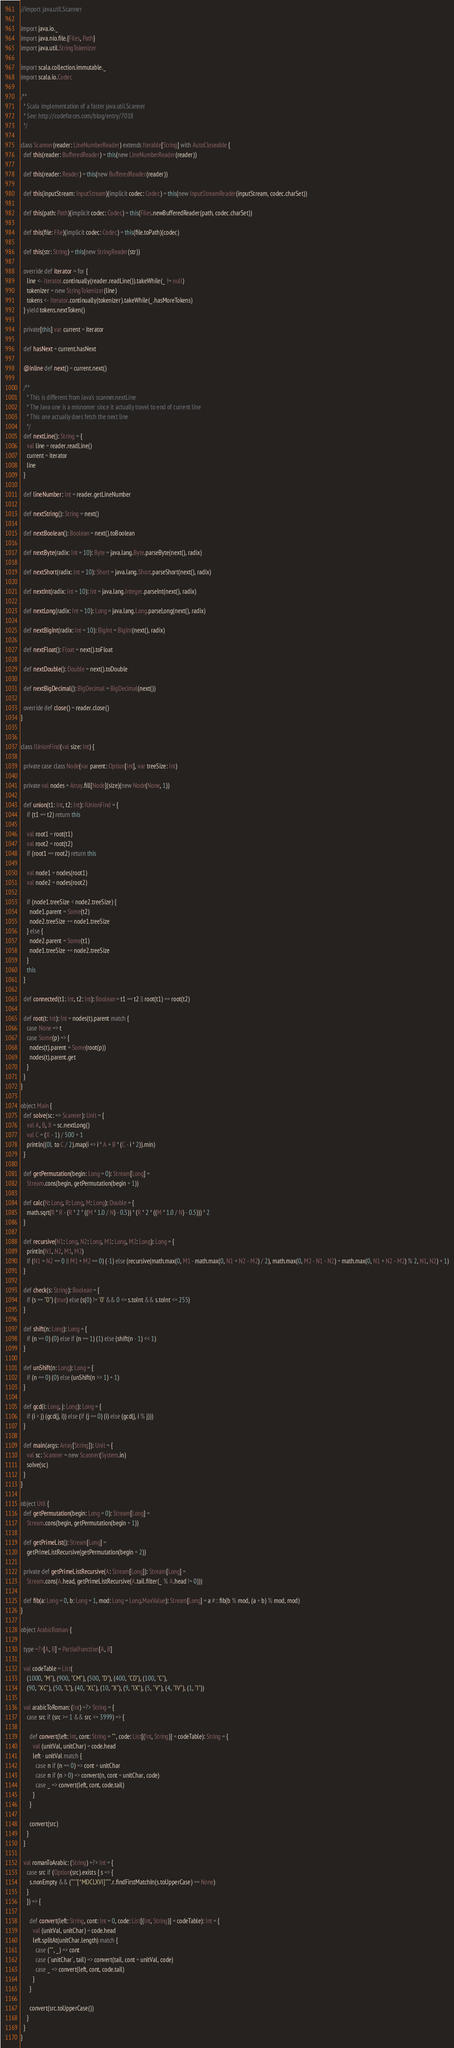<code> <loc_0><loc_0><loc_500><loc_500><_Scala_>//import java.util.Scanner

import java.io._
import java.nio.file.{Files, Path}
import java.util.StringTokenizer

import scala.collection.immutable._
import scala.io.Codec

/**
  * Scala implementation of a faster java.util.Scanner
  * See: http://codeforces.com/blog/entry/7018
  */

class Scanner(reader: LineNumberReader) extends Iterable[String] with AutoCloseable {
  def this(reader: BufferedReader) = this(new LineNumberReader(reader))

  def this(reader: Reader) = this(new BufferedReader(reader))

  def this(inputStream: InputStream)(implicit codec: Codec) = this(new InputStreamReader(inputStream, codec.charSet))

  def this(path: Path)(implicit codec: Codec) = this(Files.newBufferedReader(path, codec.charSet))

  def this(file: File)(implicit codec: Codec) = this(file.toPath)(codec)

  def this(str: String) = this(new StringReader(str))

  override def iterator = for {
    line <- Iterator.continually(reader.readLine()).takeWhile(_ != null)
    tokenizer = new StringTokenizer(line)
    tokens <- Iterator.continually(tokenizer).takeWhile(_.hasMoreTokens)
  } yield tokens.nextToken()

  private[this] var current = iterator

  def hasNext = current.hasNext

  @inline def next() = current.next()

  /**
    * This is different from Java's scanner.nextLine
    * The Java one is a misnomer since it actually travel to end of current line
    * This one actually does fetch the next line
    */
  def nextLine(): String = {
    val line = reader.readLine()
    current = iterator
    line
  }

  def lineNumber: Int = reader.getLineNumber

  def nextString(): String = next()

  def nextBoolean(): Boolean = next().toBoolean

  def nextByte(radix: Int = 10): Byte = java.lang.Byte.parseByte(next(), radix)

  def nextShort(radix: Int = 10): Short = java.lang.Short.parseShort(next(), radix)

  def nextInt(radix: Int = 10): Int = java.lang.Integer.parseInt(next(), radix)

  def nextLong(radix: Int = 10): Long = java.lang.Long.parseLong(next(), radix)

  def nextBigInt(radix: Int = 10): BigInt = BigInt(next(), radix)

  def nextFloat(): Float = next().toFloat

  def nextDouble(): Double = next().toDouble

  def nextBigDecimal(): BigDecimal = BigDecimal(next())

  override def close() = reader.close()
}


class IUnionFind(val size: Int) {

  private case class Node(var parent: Option[Int], var treeSize: Int)

  private val nodes = Array.fill[Node](size)(new Node(None, 1))

  def union(t1: Int, t2: Int): IUnionFind = {
    if (t1 == t2) return this

    val root1 = root(t1)
    val root2 = root(t2)
    if (root1 == root2) return this

    val node1 = nodes(root1)
    val node2 = nodes(root2)

    if (node1.treeSize < node2.treeSize) {
      node1.parent = Some(t2)
      node2.treeSize += node1.treeSize
    } else {
      node2.parent = Some(t1)
      node1.treeSize += node2.treeSize
    }
    this
  }

  def connected(t1: Int, t2: Int): Boolean = t1 == t2 || root(t1) == root(t2)

  def root(t: Int): Int = nodes(t).parent match {
    case None => t
    case Some(p) => {
      nodes(t).parent = Some(root(p))
      nodes(t).parent.get
    }
  }
}

object Main {
  def solve(sc: => Scanner): Unit = {
    val A, B, X = sc.nextLong()
    val C = (X - 1) / 500 + 1
    println((0L to C / 2).map(i => i * A + B * (C - i * 2)).min)
  }

  def getPermutation(begin: Long = 0): Stream[Long] =
    Stream.cons(begin, getPermutation(begin + 1))

  def calc(N: Long, R: Long, M: Long): Double = {
    math.sqrt(R * R - (R * 2 * ((M * 1.0 / N) - 0.5)) * (R * 2 * ((M * 1.0 / N) - 0.5))) * 2
  }

  def recursive(N1: Long, N2: Long, M1: Long, M2: Long): Long = {
    println(N1, N2, M1, M2)
    if (N1 + N2 == 0 || M1 + M2 == 0) (-1) else (recursive(math.max(0, M1 - math.max(0, N1 + N2 - M2) / 2), math.max(0, M2 - N1 - N2) + math.max(0, N1 + N2 - M2) % 2, N1, N2) + 1)
  }

  def check(s: String): Boolean = {
    if (s == "0") (true) else (s(0) != '0' && 0 <= s.toInt && s.toInt <= 255)
  }

  def shift(n: Long): Long = {
    if (n == 0) (0) else if (n == 1) (1) else (shift(n - 1) << 1)
  }

  def unShift(n: Long): Long = {
    if (n == 0) (0) else (unShift(n >> 1) + 1)
  }

  def gcd(i: Long, j: Long): Long = {
    if (i < j) (gcd(j, i)) else (if (j == 0) (i) else (gcd(j, i % j)))
  }

  def main(args: Array[String]): Unit = {
    val sc: Scanner = new Scanner(System.in)
    solve(sc)
  }
}

object Util {
  def getPermutation(begin: Long = 0): Stream[Long] =
    Stream.cons(begin, getPermutation(begin + 1))

  def getPrimeList(): Stream[Long] =
    getPrimeListRecursive(getPermutation(begin = 2))

  private def getPrimeListRecursive(A: Stream[Long]): Stream[Long] =
    Stream.cons(A.head, getPrimeListRecursive(A.tail.filter(_ % A.head != 0)))

  def fib(a: Long = 0, b: Long = 1, mod: Long = Long.MaxValue): Stream[Long] = a #:: fib(b % mod, (a + b) % mod, mod)
}

object ArabicRoman {

  type =?>[A, B] = PartialFunction[A, B]

  val codeTable = List(
    (1000, "M"), (900, "CM"), (500, "D"), (400, "CD"), (100, "C"),
    (90, "XC"), (50, "L"), (40, "XL"), (10, "X"), (9, "IX"), (5, "V"), (4, "IV"), (1, "I"))

  val arabicToRoman: (Int) =?> String = {
    case src if (src >= 1 && src <= 3999) => {

      def convert(left: Int, cont: String = "", code: List[(Int, String)] = codeTable): String = {
        val (unitVal, unitChar) = code.head
        left - unitVal match {
          case n if (n == 0) => cont + unitChar
          case n if (n > 0) => convert(n, cont + unitChar, code)
          case _ => convert(left, cont, code.tail)
        }
      }

      convert(src)
    }
  }

  val romanToArabic: (String) =?> Int = {
    case src if (Option(src).exists { s => {
      s.nonEmpty && ("""[^MDCLXVI]""".r.findFirstMatchIn(s.toUpperCase) == None)
    }
    }) => {

      def convert(left: String, cont: Int = 0, code: List[(Int, String)] = codeTable): Int = {
        val (unitVal, unitChar) = code.head
        left.splitAt(unitChar.length) match {
          case ("", _) => cont
          case (`unitChar`, tail) => convert(tail, cont + unitVal, code)
          case _ => convert(left, cont, code.tail)
        }
      }

      convert(src.toUpperCase())
    }
  }
}

</code> 